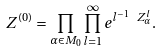<formula> <loc_0><loc_0><loc_500><loc_500>Z ^ { ( 0 ) } = \prod _ { \alpha \in M _ { 0 } } \prod _ { l = 1 } ^ { \infty } e ^ { l ^ { - 1 } \ Z _ { \alpha } ^ { l } } .</formula> 